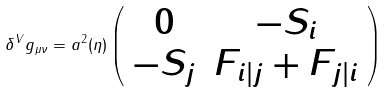<formula> <loc_0><loc_0><loc_500><loc_500>\delta ^ { V } g _ { \mu \nu } = a ^ { 2 } ( \eta ) \left ( \begin{array} { c c } 0 & - S _ { i } \\ - S _ { j } & F _ { i | j } + F _ { j | i } \end{array} \right )</formula> 